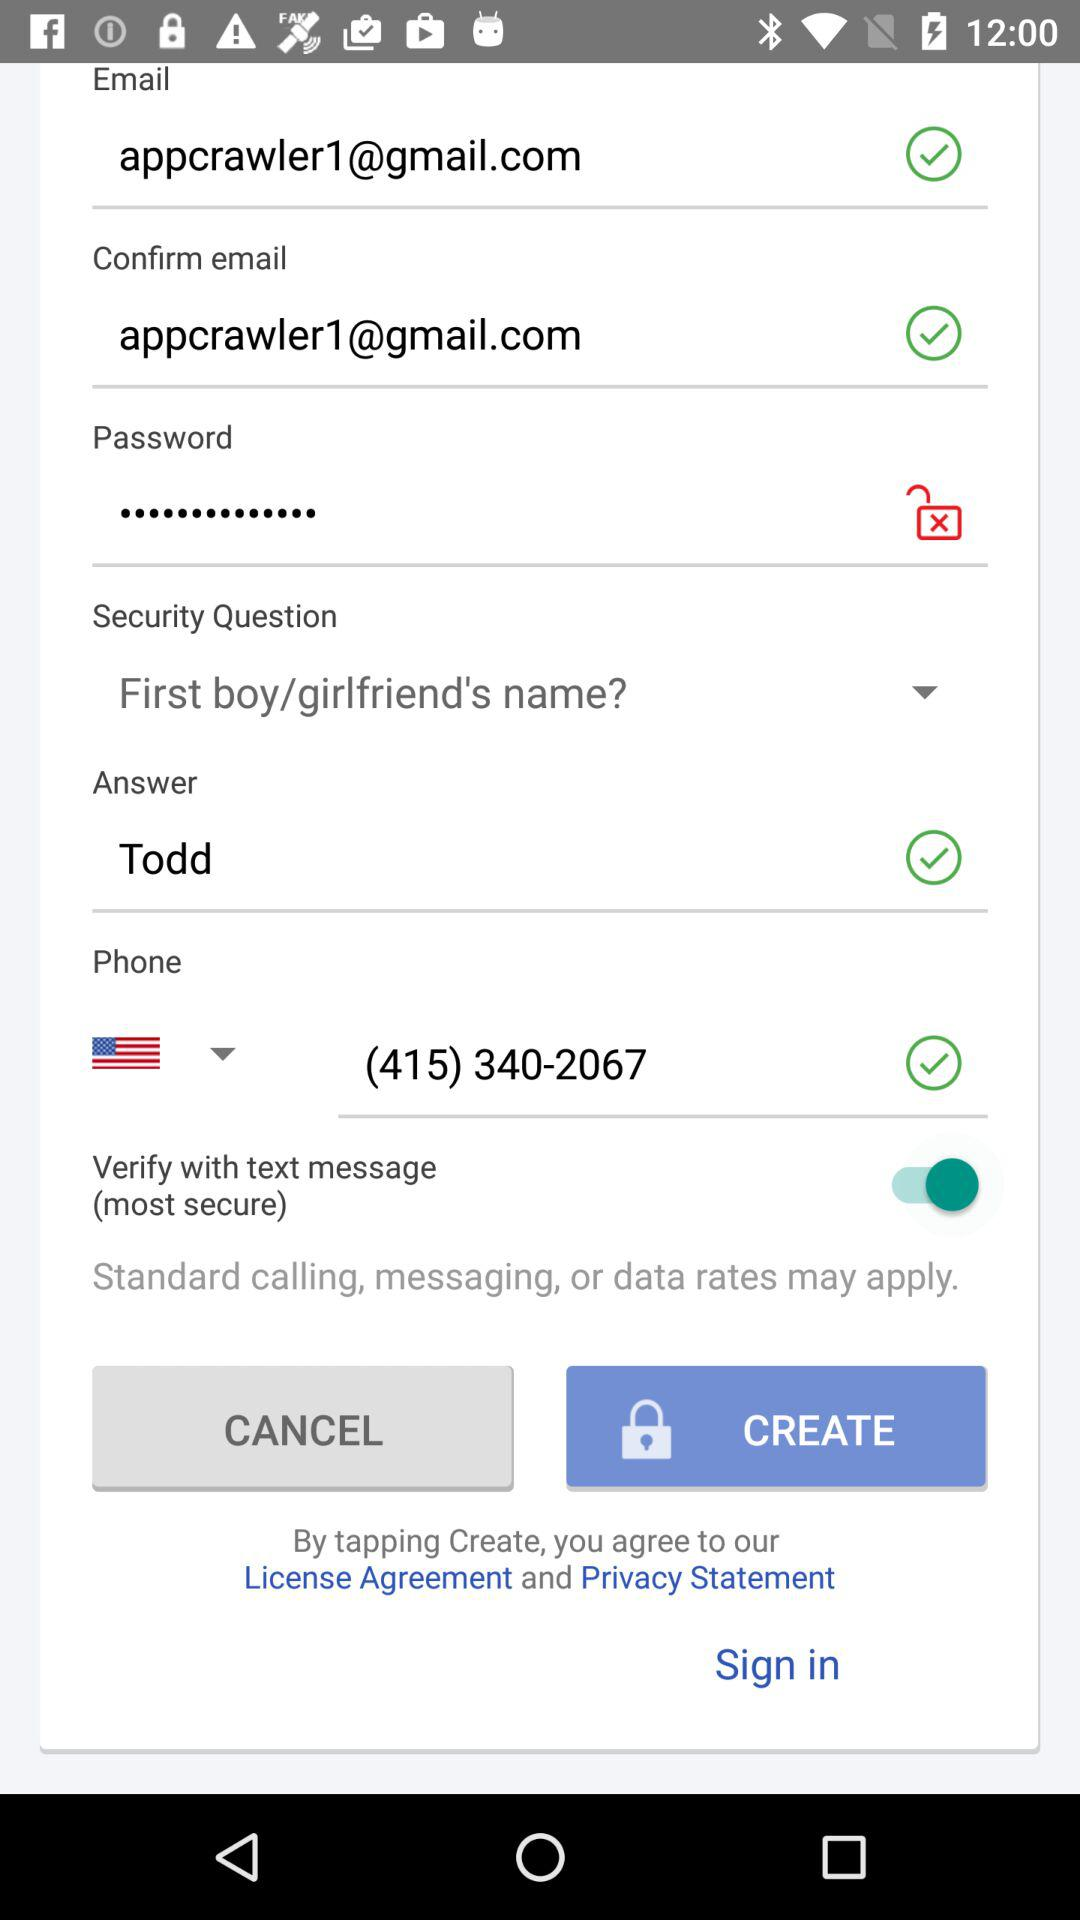What is the email address? The email address is appcrawler1@gmail.com. 